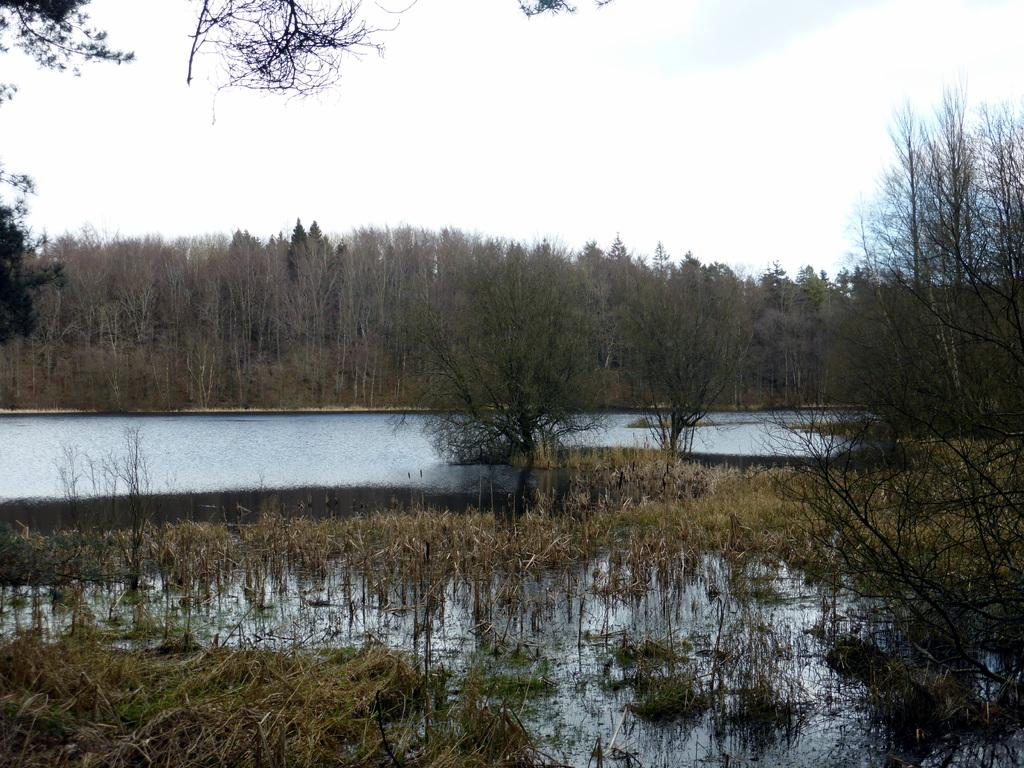What type of setting is depicted in the image? The image has an outside view. What body of water can be seen in the image? There is a lake in the image. What type of vegetation is present around the lake? Trees are present around the lake. What is visible at the top of the image? The sky is visible at the top of the image. What is the name of the person standing next to the lake in the image? There is no person standing next to the lake in the image. What type of straw is used to drink from the lake in the image? There is no straw present in the image, and people do not typically drink directly from lakes. 